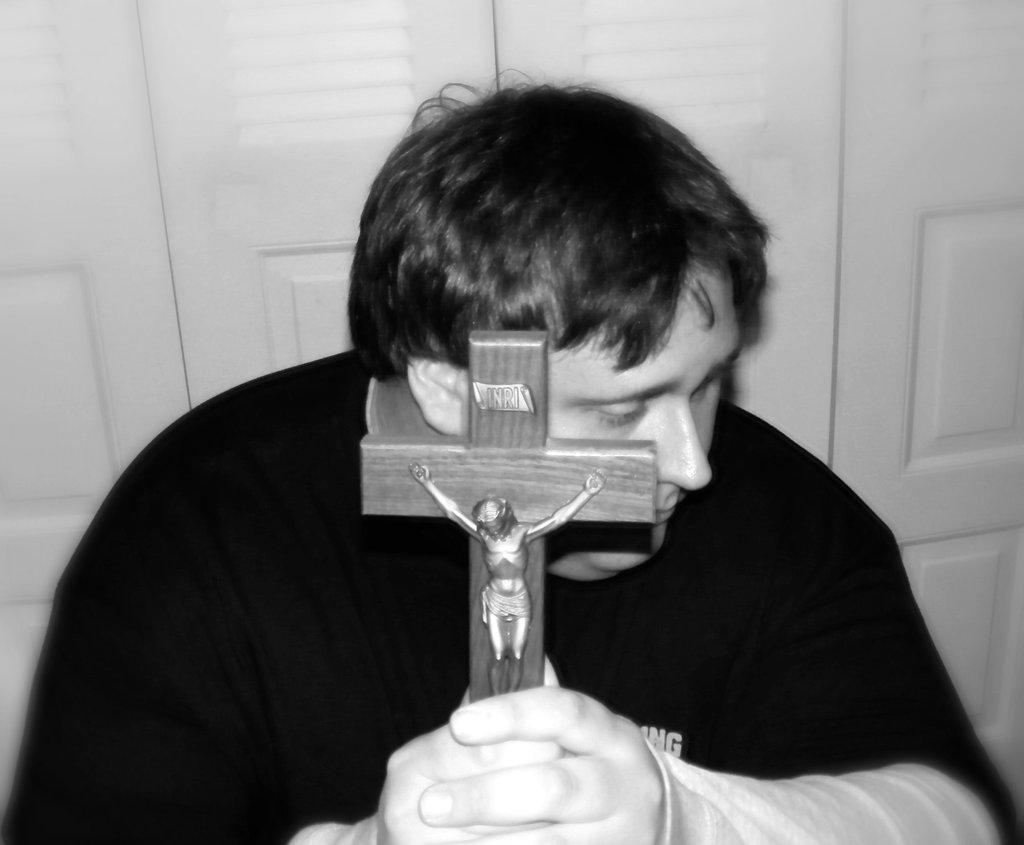What is the person in the image holding? The person is holding a cross symbol in the image. Is there anything on the cross symbol? Yes, there is a statue on the cross symbol. What is the color scheme of the image? The image is in black and white. How does the cactus make the person feel in the image? There is no cactus present in the image, so it cannot make the person feel anything. 